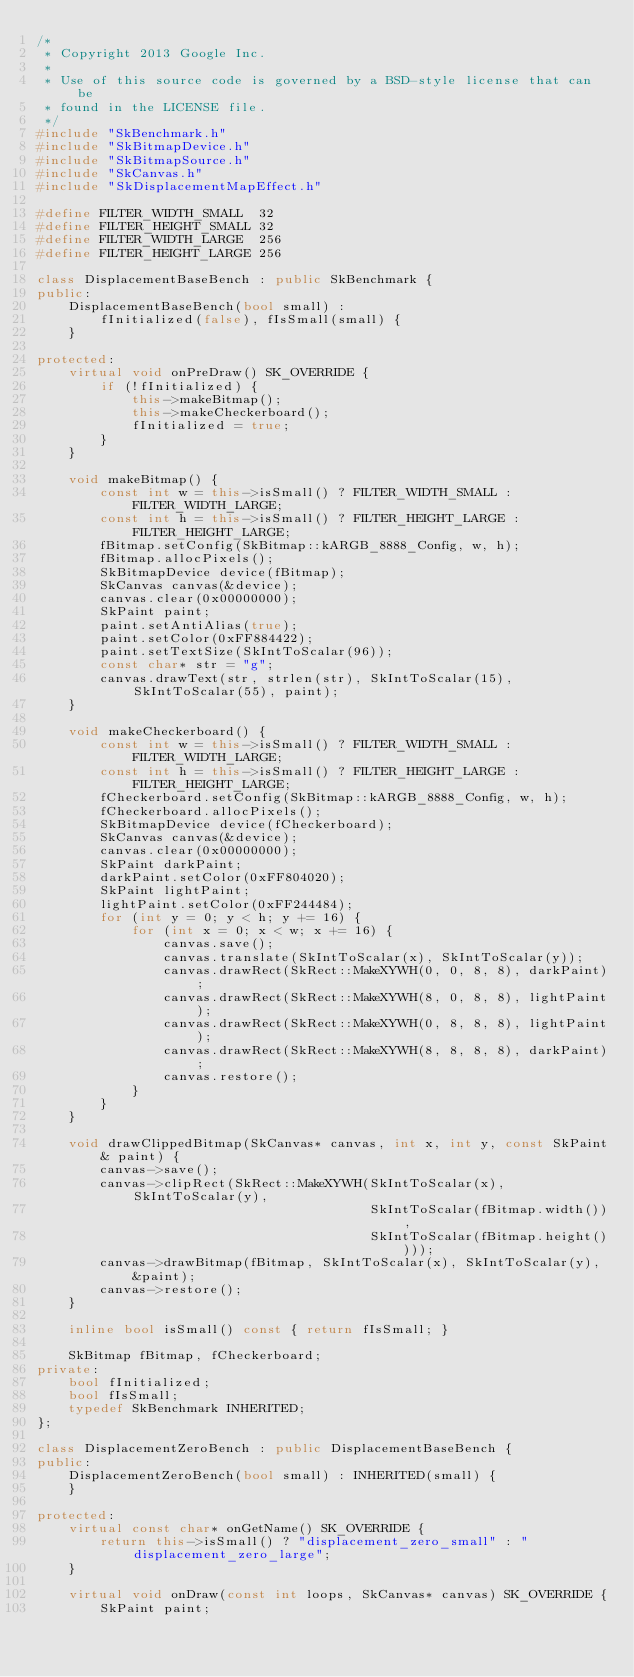Convert code to text. <code><loc_0><loc_0><loc_500><loc_500><_C++_>/*
 * Copyright 2013 Google Inc.
 *
 * Use of this source code is governed by a BSD-style license that can be
 * found in the LICENSE file.
 */
#include "SkBenchmark.h"
#include "SkBitmapDevice.h"
#include "SkBitmapSource.h"
#include "SkCanvas.h"
#include "SkDisplacementMapEffect.h"

#define FILTER_WIDTH_SMALL  32
#define FILTER_HEIGHT_SMALL 32
#define FILTER_WIDTH_LARGE  256
#define FILTER_HEIGHT_LARGE 256

class DisplacementBaseBench : public SkBenchmark {
public:
    DisplacementBaseBench(bool small) :
        fInitialized(false), fIsSmall(small) {
    }

protected:
    virtual void onPreDraw() SK_OVERRIDE {
        if (!fInitialized) {
            this->makeBitmap();
            this->makeCheckerboard();
            fInitialized = true;
        }
    }

    void makeBitmap() {
        const int w = this->isSmall() ? FILTER_WIDTH_SMALL : FILTER_WIDTH_LARGE;
        const int h = this->isSmall() ? FILTER_HEIGHT_LARGE : FILTER_HEIGHT_LARGE;
        fBitmap.setConfig(SkBitmap::kARGB_8888_Config, w, h);
        fBitmap.allocPixels();
        SkBitmapDevice device(fBitmap);
        SkCanvas canvas(&device);
        canvas.clear(0x00000000);
        SkPaint paint;
        paint.setAntiAlias(true);
        paint.setColor(0xFF884422);
        paint.setTextSize(SkIntToScalar(96));
        const char* str = "g";
        canvas.drawText(str, strlen(str), SkIntToScalar(15), SkIntToScalar(55), paint);
    }

    void makeCheckerboard() {
        const int w = this->isSmall() ? FILTER_WIDTH_SMALL : FILTER_WIDTH_LARGE;
        const int h = this->isSmall() ? FILTER_HEIGHT_LARGE : FILTER_HEIGHT_LARGE;
        fCheckerboard.setConfig(SkBitmap::kARGB_8888_Config, w, h);
        fCheckerboard.allocPixels();
        SkBitmapDevice device(fCheckerboard);
        SkCanvas canvas(&device);
        canvas.clear(0x00000000);
        SkPaint darkPaint;
        darkPaint.setColor(0xFF804020);
        SkPaint lightPaint;
        lightPaint.setColor(0xFF244484);
        for (int y = 0; y < h; y += 16) {
            for (int x = 0; x < w; x += 16) {
                canvas.save();
                canvas.translate(SkIntToScalar(x), SkIntToScalar(y));
                canvas.drawRect(SkRect::MakeXYWH(0, 0, 8, 8), darkPaint);
                canvas.drawRect(SkRect::MakeXYWH(8, 0, 8, 8), lightPaint);
                canvas.drawRect(SkRect::MakeXYWH(0, 8, 8, 8), lightPaint);
                canvas.drawRect(SkRect::MakeXYWH(8, 8, 8, 8), darkPaint);
                canvas.restore();
            }
        }
    }

    void drawClippedBitmap(SkCanvas* canvas, int x, int y, const SkPaint& paint) {
        canvas->save();
        canvas->clipRect(SkRect::MakeXYWH(SkIntToScalar(x), SkIntToScalar(y),
                                          SkIntToScalar(fBitmap.width()),
                                          SkIntToScalar(fBitmap.height())));
        canvas->drawBitmap(fBitmap, SkIntToScalar(x), SkIntToScalar(y), &paint);
        canvas->restore();
    }

    inline bool isSmall() const { return fIsSmall; }

    SkBitmap fBitmap, fCheckerboard;
private:
    bool fInitialized;
    bool fIsSmall;
    typedef SkBenchmark INHERITED;
};

class DisplacementZeroBench : public DisplacementBaseBench {
public:
    DisplacementZeroBench(bool small) : INHERITED(small) {
    }

protected:
    virtual const char* onGetName() SK_OVERRIDE {
        return this->isSmall() ? "displacement_zero_small" : "displacement_zero_large";
    }

    virtual void onDraw(const int loops, SkCanvas* canvas) SK_OVERRIDE {
        SkPaint paint;</code> 